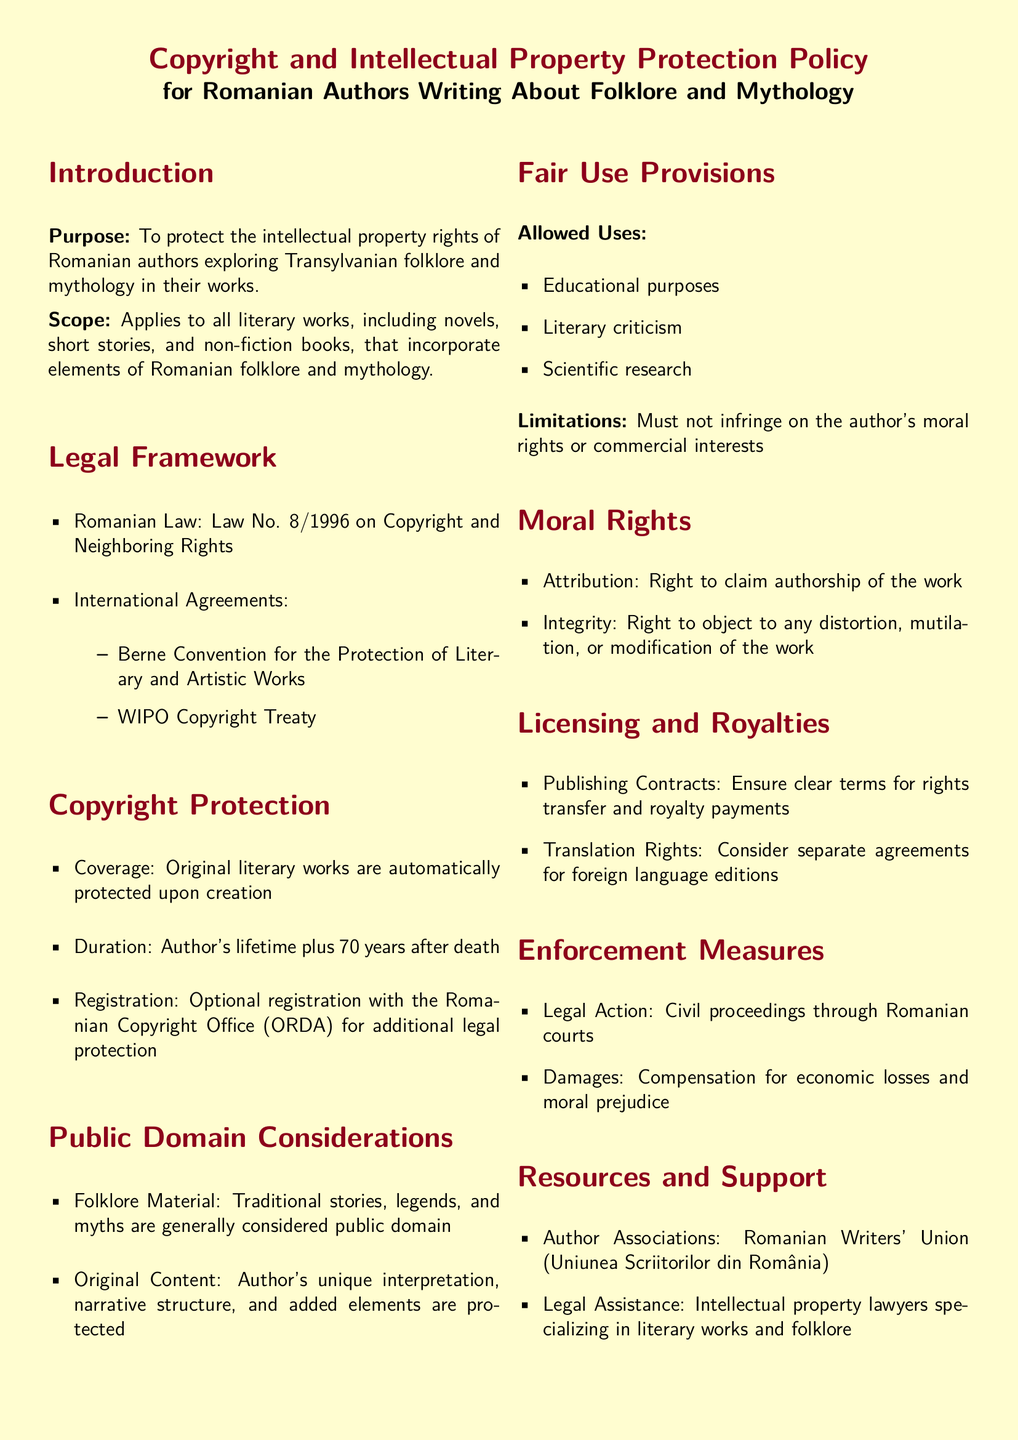What is the purpose of this policy? The purpose is to protect the intellectual property rights of Romanian authors exploring Transylvanian folklore and mythology in their works.
Answer: To protect the intellectual property rights of Romanian authors What is the duration of copyright protection? The duration of copyright protection is specified in the document as the author's lifetime plus 70 years after death.
Answer: Author's lifetime plus 70 years after death What law governs copyright in Romania? The document specifies Law No. 8/1996 on Copyright and Neighboring Rights as the governing law for copyright in Romania.
Answer: Law No. 8/1996 on Copyright and Neighboring Rights What rights are an author granted under moral rights? The author is granted rights of attribution and integrity under moral rights.
Answer: Attribution and integrity What types of uses are allowed under fair use provisions? Allowed uses under fair use provisions include educational purposes, literary criticism, and scientific research.
Answer: Educational purposes, literary criticism, scientific research What optional action can authors take for additional legal protection? The document mentions that authors can optionally register their works with the Romanian Copyright Office (ORDA) for additional legal protection.
Answer: Register with the Romanian Copyright Office (ORDA) What should publishing contracts ensure? Publishing contracts should ensure clear terms for rights transfer and royalty payments.
Answer: Clear terms for rights transfer and royalty payments What is the main objective of enforcement measures mentioned? The enforcement measures aim to provide a framework for legal actions and compensation for damages incurred.
Answer: Legal action and compensation for damages What organization provides support for Romanian authors? The Romanian Writers' Union is mentioned as an organization that provides support for authors.
Answer: Romanian Writers' Union 